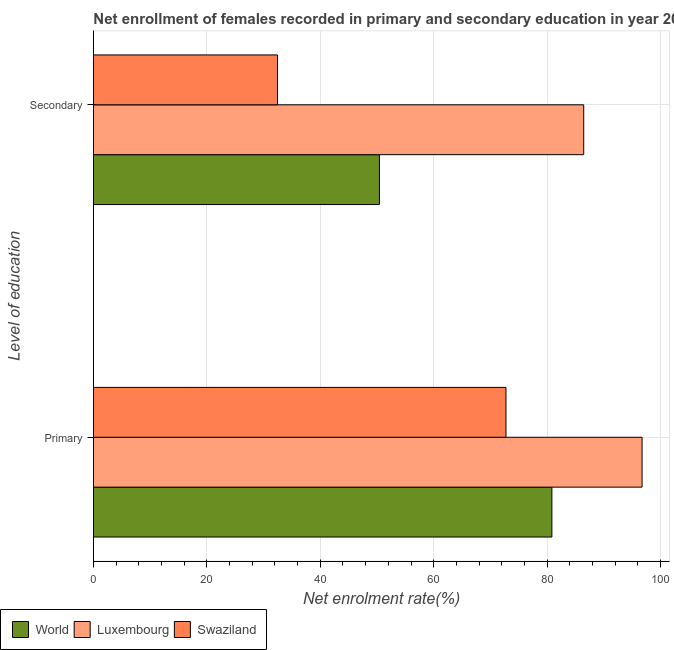How many different coloured bars are there?
Make the answer very short. 3. What is the label of the 2nd group of bars from the top?
Your answer should be compact. Primary. What is the enrollment rate in primary education in Luxembourg?
Offer a very short reply. 96.75. Across all countries, what is the maximum enrollment rate in secondary education?
Provide a succinct answer. 86.46. Across all countries, what is the minimum enrollment rate in primary education?
Ensure brevity in your answer.  72.75. In which country was the enrollment rate in secondary education maximum?
Offer a terse response. Luxembourg. In which country was the enrollment rate in primary education minimum?
Your answer should be very brief. Swaziland. What is the total enrollment rate in primary education in the graph?
Ensure brevity in your answer.  250.34. What is the difference between the enrollment rate in primary education in Luxembourg and that in World?
Make the answer very short. 15.9. What is the difference between the enrollment rate in secondary education in Swaziland and the enrollment rate in primary education in World?
Your response must be concise. -48.39. What is the average enrollment rate in primary education per country?
Your response must be concise. 83.45. What is the difference between the enrollment rate in primary education and enrollment rate in secondary education in Swaziland?
Make the answer very short. 40.29. What is the ratio of the enrollment rate in primary education in World to that in Swaziland?
Your answer should be compact. 1.11. Is the enrollment rate in secondary education in Luxembourg less than that in World?
Your answer should be compact. No. In how many countries, is the enrollment rate in secondary education greater than the average enrollment rate in secondary education taken over all countries?
Offer a very short reply. 1. What does the 3rd bar from the top in Primary represents?
Provide a short and direct response. World. What does the 3rd bar from the bottom in Secondary represents?
Your answer should be compact. Swaziland. How many countries are there in the graph?
Give a very brief answer. 3. Does the graph contain any zero values?
Your answer should be very brief. No. Does the graph contain grids?
Ensure brevity in your answer.  Yes. Where does the legend appear in the graph?
Your answer should be very brief. Bottom left. What is the title of the graph?
Offer a very short reply. Net enrollment of females recorded in primary and secondary education in year 2000. What is the label or title of the X-axis?
Offer a terse response. Net enrolment rate(%). What is the label or title of the Y-axis?
Offer a terse response. Level of education. What is the Net enrolment rate(%) of World in Primary?
Your answer should be very brief. 80.85. What is the Net enrolment rate(%) of Luxembourg in Primary?
Make the answer very short. 96.75. What is the Net enrolment rate(%) of Swaziland in Primary?
Keep it short and to the point. 72.75. What is the Net enrolment rate(%) of World in Secondary?
Provide a succinct answer. 50.43. What is the Net enrolment rate(%) in Luxembourg in Secondary?
Offer a very short reply. 86.46. What is the Net enrolment rate(%) of Swaziland in Secondary?
Ensure brevity in your answer.  32.45. Across all Level of education, what is the maximum Net enrolment rate(%) in World?
Your answer should be compact. 80.85. Across all Level of education, what is the maximum Net enrolment rate(%) in Luxembourg?
Your answer should be very brief. 96.75. Across all Level of education, what is the maximum Net enrolment rate(%) in Swaziland?
Give a very brief answer. 72.75. Across all Level of education, what is the minimum Net enrolment rate(%) of World?
Provide a succinct answer. 50.43. Across all Level of education, what is the minimum Net enrolment rate(%) in Luxembourg?
Provide a succinct answer. 86.46. Across all Level of education, what is the minimum Net enrolment rate(%) in Swaziland?
Offer a terse response. 32.45. What is the total Net enrolment rate(%) of World in the graph?
Ensure brevity in your answer.  131.28. What is the total Net enrolment rate(%) of Luxembourg in the graph?
Keep it short and to the point. 183.21. What is the total Net enrolment rate(%) in Swaziland in the graph?
Keep it short and to the point. 105.2. What is the difference between the Net enrolment rate(%) of World in Primary and that in Secondary?
Give a very brief answer. 30.41. What is the difference between the Net enrolment rate(%) in Luxembourg in Primary and that in Secondary?
Your response must be concise. 10.29. What is the difference between the Net enrolment rate(%) of Swaziland in Primary and that in Secondary?
Provide a succinct answer. 40.29. What is the difference between the Net enrolment rate(%) in World in Primary and the Net enrolment rate(%) in Luxembourg in Secondary?
Your answer should be compact. -5.61. What is the difference between the Net enrolment rate(%) of World in Primary and the Net enrolment rate(%) of Swaziland in Secondary?
Offer a very short reply. 48.39. What is the difference between the Net enrolment rate(%) in Luxembourg in Primary and the Net enrolment rate(%) in Swaziland in Secondary?
Give a very brief answer. 64.29. What is the average Net enrolment rate(%) of World per Level of education?
Provide a short and direct response. 65.64. What is the average Net enrolment rate(%) of Luxembourg per Level of education?
Provide a succinct answer. 91.6. What is the average Net enrolment rate(%) of Swaziland per Level of education?
Offer a terse response. 52.6. What is the difference between the Net enrolment rate(%) in World and Net enrolment rate(%) in Luxembourg in Primary?
Offer a very short reply. -15.9. What is the difference between the Net enrolment rate(%) in World and Net enrolment rate(%) in Swaziland in Primary?
Ensure brevity in your answer.  8.1. What is the difference between the Net enrolment rate(%) in Luxembourg and Net enrolment rate(%) in Swaziland in Primary?
Your answer should be compact. 24. What is the difference between the Net enrolment rate(%) in World and Net enrolment rate(%) in Luxembourg in Secondary?
Offer a terse response. -36.03. What is the difference between the Net enrolment rate(%) in World and Net enrolment rate(%) in Swaziland in Secondary?
Ensure brevity in your answer.  17.98. What is the difference between the Net enrolment rate(%) in Luxembourg and Net enrolment rate(%) in Swaziland in Secondary?
Make the answer very short. 54.01. What is the ratio of the Net enrolment rate(%) in World in Primary to that in Secondary?
Ensure brevity in your answer.  1.6. What is the ratio of the Net enrolment rate(%) of Luxembourg in Primary to that in Secondary?
Ensure brevity in your answer.  1.12. What is the ratio of the Net enrolment rate(%) of Swaziland in Primary to that in Secondary?
Make the answer very short. 2.24. What is the difference between the highest and the second highest Net enrolment rate(%) of World?
Make the answer very short. 30.41. What is the difference between the highest and the second highest Net enrolment rate(%) of Luxembourg?
Your answer should be very brief. 10.29. What is the difference between the highest and the second highest Net enrolment rate(%) in Swaziland?
Make the answer very short. 40.29. What is the difference between the highest and the lowest Net enrolment rate(%) of World?
Provide a succinct answer. 30.41. What is the difference between the highest and the lowest Net enrolment rate(%) of Luxembourg?
Make the answer very short. 10.29. What is the difference between the highest and the lowest Net enrolment rate(%) in Swaziland?
Make the answer very short. 40.29. 